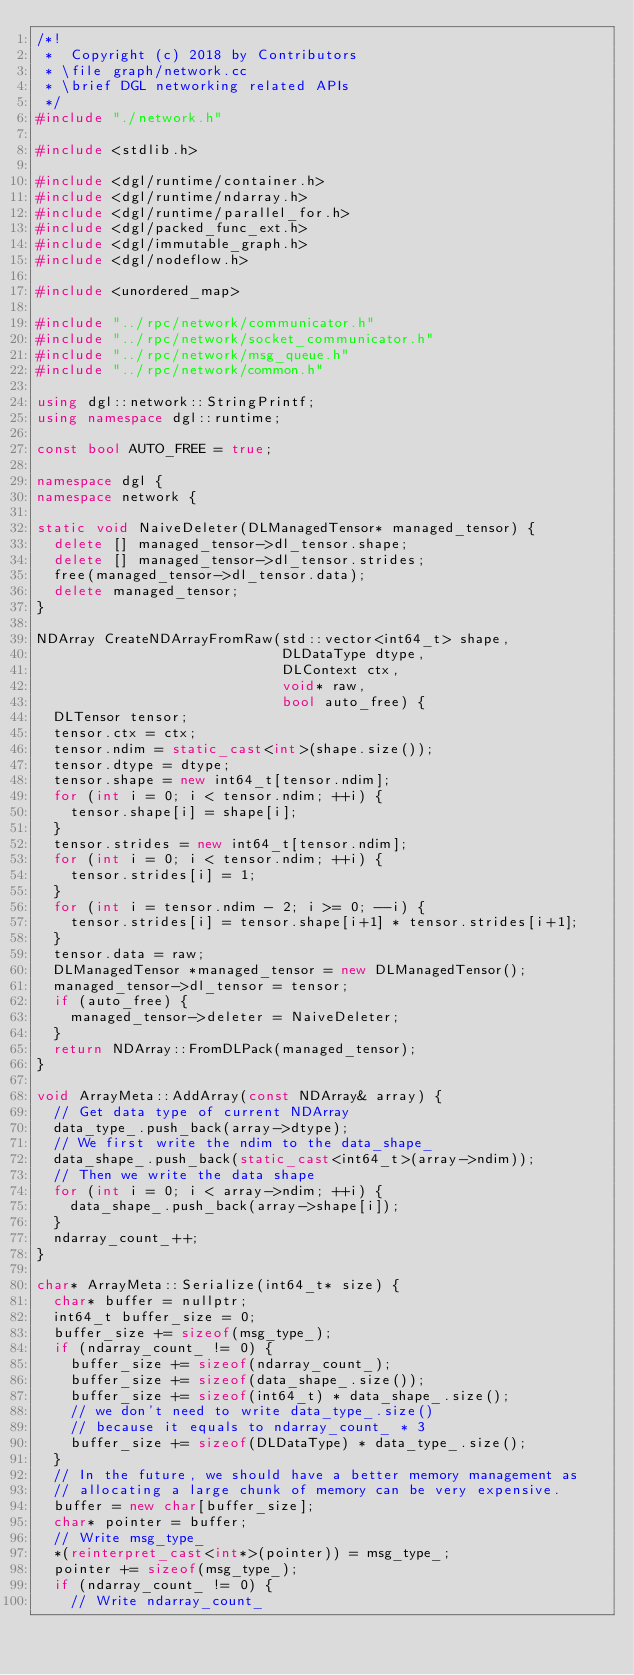Convert code to text. <code><loc_0><loc_0><loc_500><loc_500><_C++_>/*!
 *  Copyright (c) 2018 by Contributors
 * \file graph/network.cc
 * \brief DGL networking related APIs
 */
#include "./network.h"

#include <stdlib.h>

#include <dgl/runtime/container.h>
#include <dgl/runtime/ndarray.h>
#include <dgl/runtime/parallel_for.h>
#include <dgl/packed_func_ext.h>
#include <dgl/immutable_graph.h>
#include <dgl/nodeflow.h>

#include <unordered_map>

#include "../rpc/network/communicator.h"
#include "../rpc/network/socket_communicator.h"
#include "../rpc/network/msg_queue.h"
#include "../rpc/network/common.h"

using dgl::network::StringPrintf;
using namespace dgl::runtime;

const bool AUTO_FREE = true;

namespace dgl {
namespace network {

static void NaiveDeleter(DLManagedTensor* managed_tensor) {
  delete [] managed_tensor->dl_tensor.shape;
  delete [] managed_tensor->dl_tensor.strides;
  free(managed_tensor->dl_tensor.data);
  delete managed_tensor;
}

NDArray CreateNDArrayFromRaw(std::vector<int64_t> shape,
                             DLDataType dtype,
                             DLContext ctx,
                             void* raw,
                             bool auto_free) {
  DLTensor tensor;
  tensor.ctx = ctx;
  tensor.ndim = static_cast<int>(shape.size());
  tensor.dtype = dtype;
  tensor.shape = new int64_t[tensor.ndim];
  for (int i = 0; i < tensor.ndim; ++i) {
    tensor.shape[i] = shape[i];
  }
  tensor.strides = new int64_t[tensor.ndim];
  for (int i = 0; i < tensor.ndim; ++i) {
    tensor.strides[i] = 1;
  }
  for (int i = tensor.ndim - 2; i >= 0; --i) {
    tensor.strides[i] = tensor.shape[i+1] * tensor.strides[i+1];
  }
  tensor.data = raw;
  DLManagedTensor *managed_tensor = new DLManagedTensor();
  managed_tensor->dl_tensor = tensor;
  if (auto_free) {
    managed_tensor->deleter = NaiveDeleter;
  }
  return NDArray::FromDLPack(managed_tensor);
}

void ArrayMeta::AddArray(const NDArray& array) {
  // Get data type of current NDArray
  data_type_.push_back(array->dtype);
  // We first write the ndim to the data_shape_
  data_shape_.push_back(static_cast<int64_t>(array->ndim));
  // Then we write the data shape
  for (int i = 0; i < array->ndim; ++i) {
    data_shape_.push_back(array->shape[i]);
  }
  ndarray_count_++;
}

char* ArrayMeta::Serialize(int64_t* size) {
  char* buffer = nullptr;
  int64_t buffer_size = 0;
  buffer_size += sizeof(msg_type_);
  if (ndarray_count_ != 0) {
    buffer_size += sizeof(ndarray_count_);
    buffer_size += sizeof(data_shape_.size());
    buffer_size += sizeof(int64_t) * data_shape_.size();
    // we don't need to write data_type_.size()
    // because it equals to ndarray_count_ * 3
    buffer_size += sizeof(DLDataType) * data_type_.size();
  }
  // In the future, we should have a better memory management as
  // allocating a large chunk of memory can be very expensive.
  buffer = new char[buffer_size];
  char* pointer = buffer;
  // Write msg_type_
  *(reinterpret_cast<int*>(pointer)) = msg_type_;
  pointer += sizeof(msg_type_);
  if (ndarray_count_ != 0) {
    // Write ndarray_count_</code> 